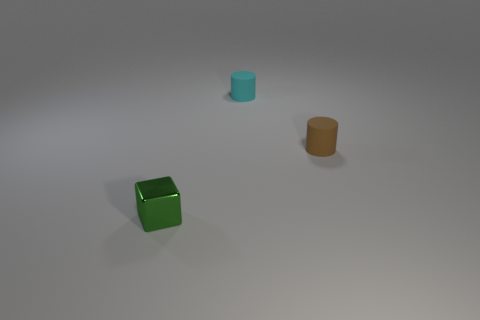Add 2 small brown rubber cylinders. How many objects exist? 5 Subtract all cubes. How many objects are left? 2 Add 3 small green metallic things. How many small green metallic things exist? 4 Subtract 0 purple blocks. How many objects are left? 3 Subtract all metallic blocks. Subtract all small green objects. How many objects are left? 1 Add 3 cyan cylinders. How many cyan cylinders are left? 4 